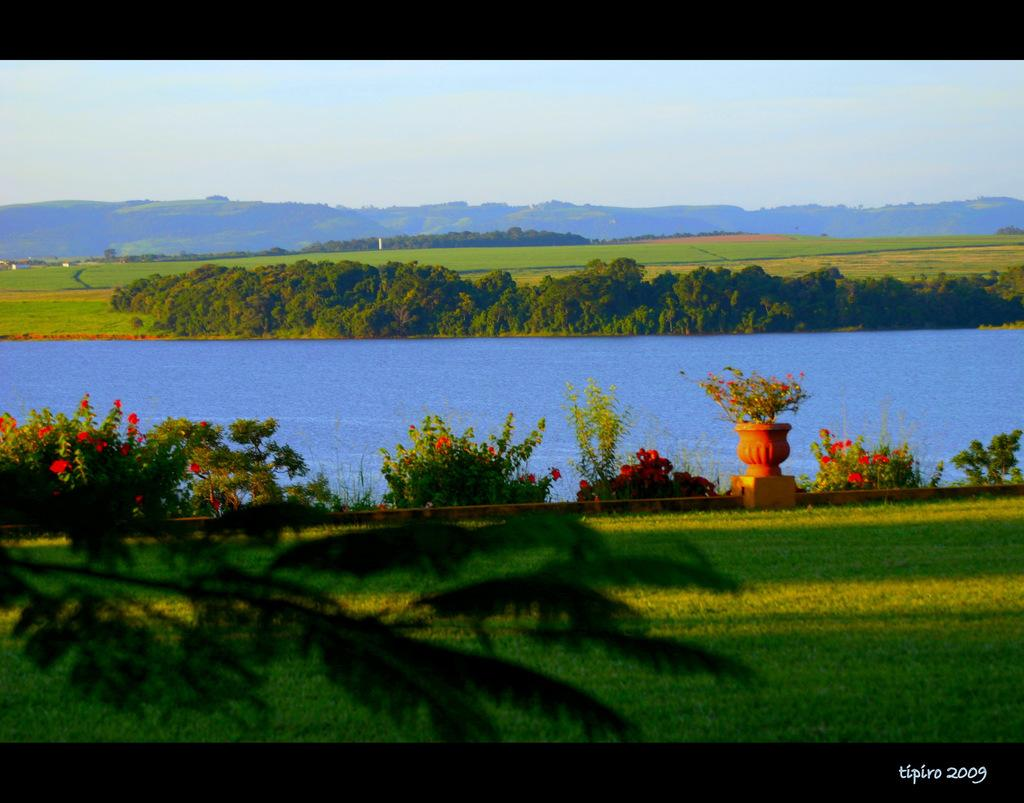What type of vegetation can be seen in the image? There is grass, plants, and flowers visible in the image. What can be seen in the background of the image? There is water, trees, and hills visible in the background of the image. Can you describe the natural environment depicted in the image? The image features a grassy area with plants, flowers, and a body of water in the background, surrounded by trees and hills. What book is the person reading under the umbrella in the image? There is no person, umbrella, or book present in the image. What type of knowledge can be gained from the flowers in the image? The flowers in the image are not a source of knowledge; they are a part of the natural environment depicted. 